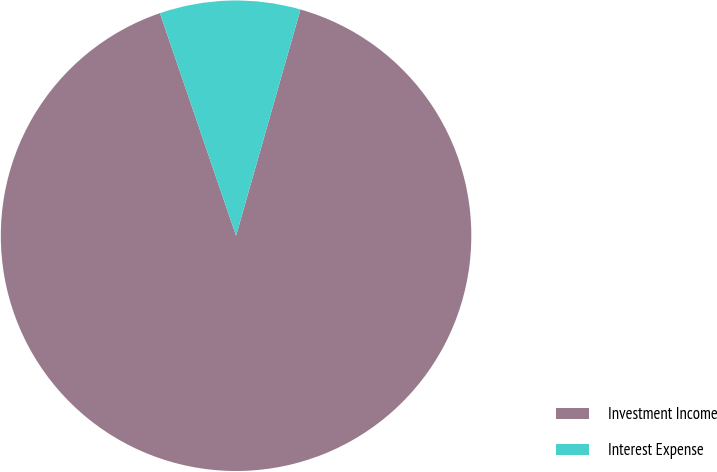Convert chart. <chart><loc_0><loc_0><loc_500><loc_500><pie_chart><fcel>Investment Income<fcel>Interest Expense<nl><fcel>90.34%<fcel>9.66%<nl></chart> 